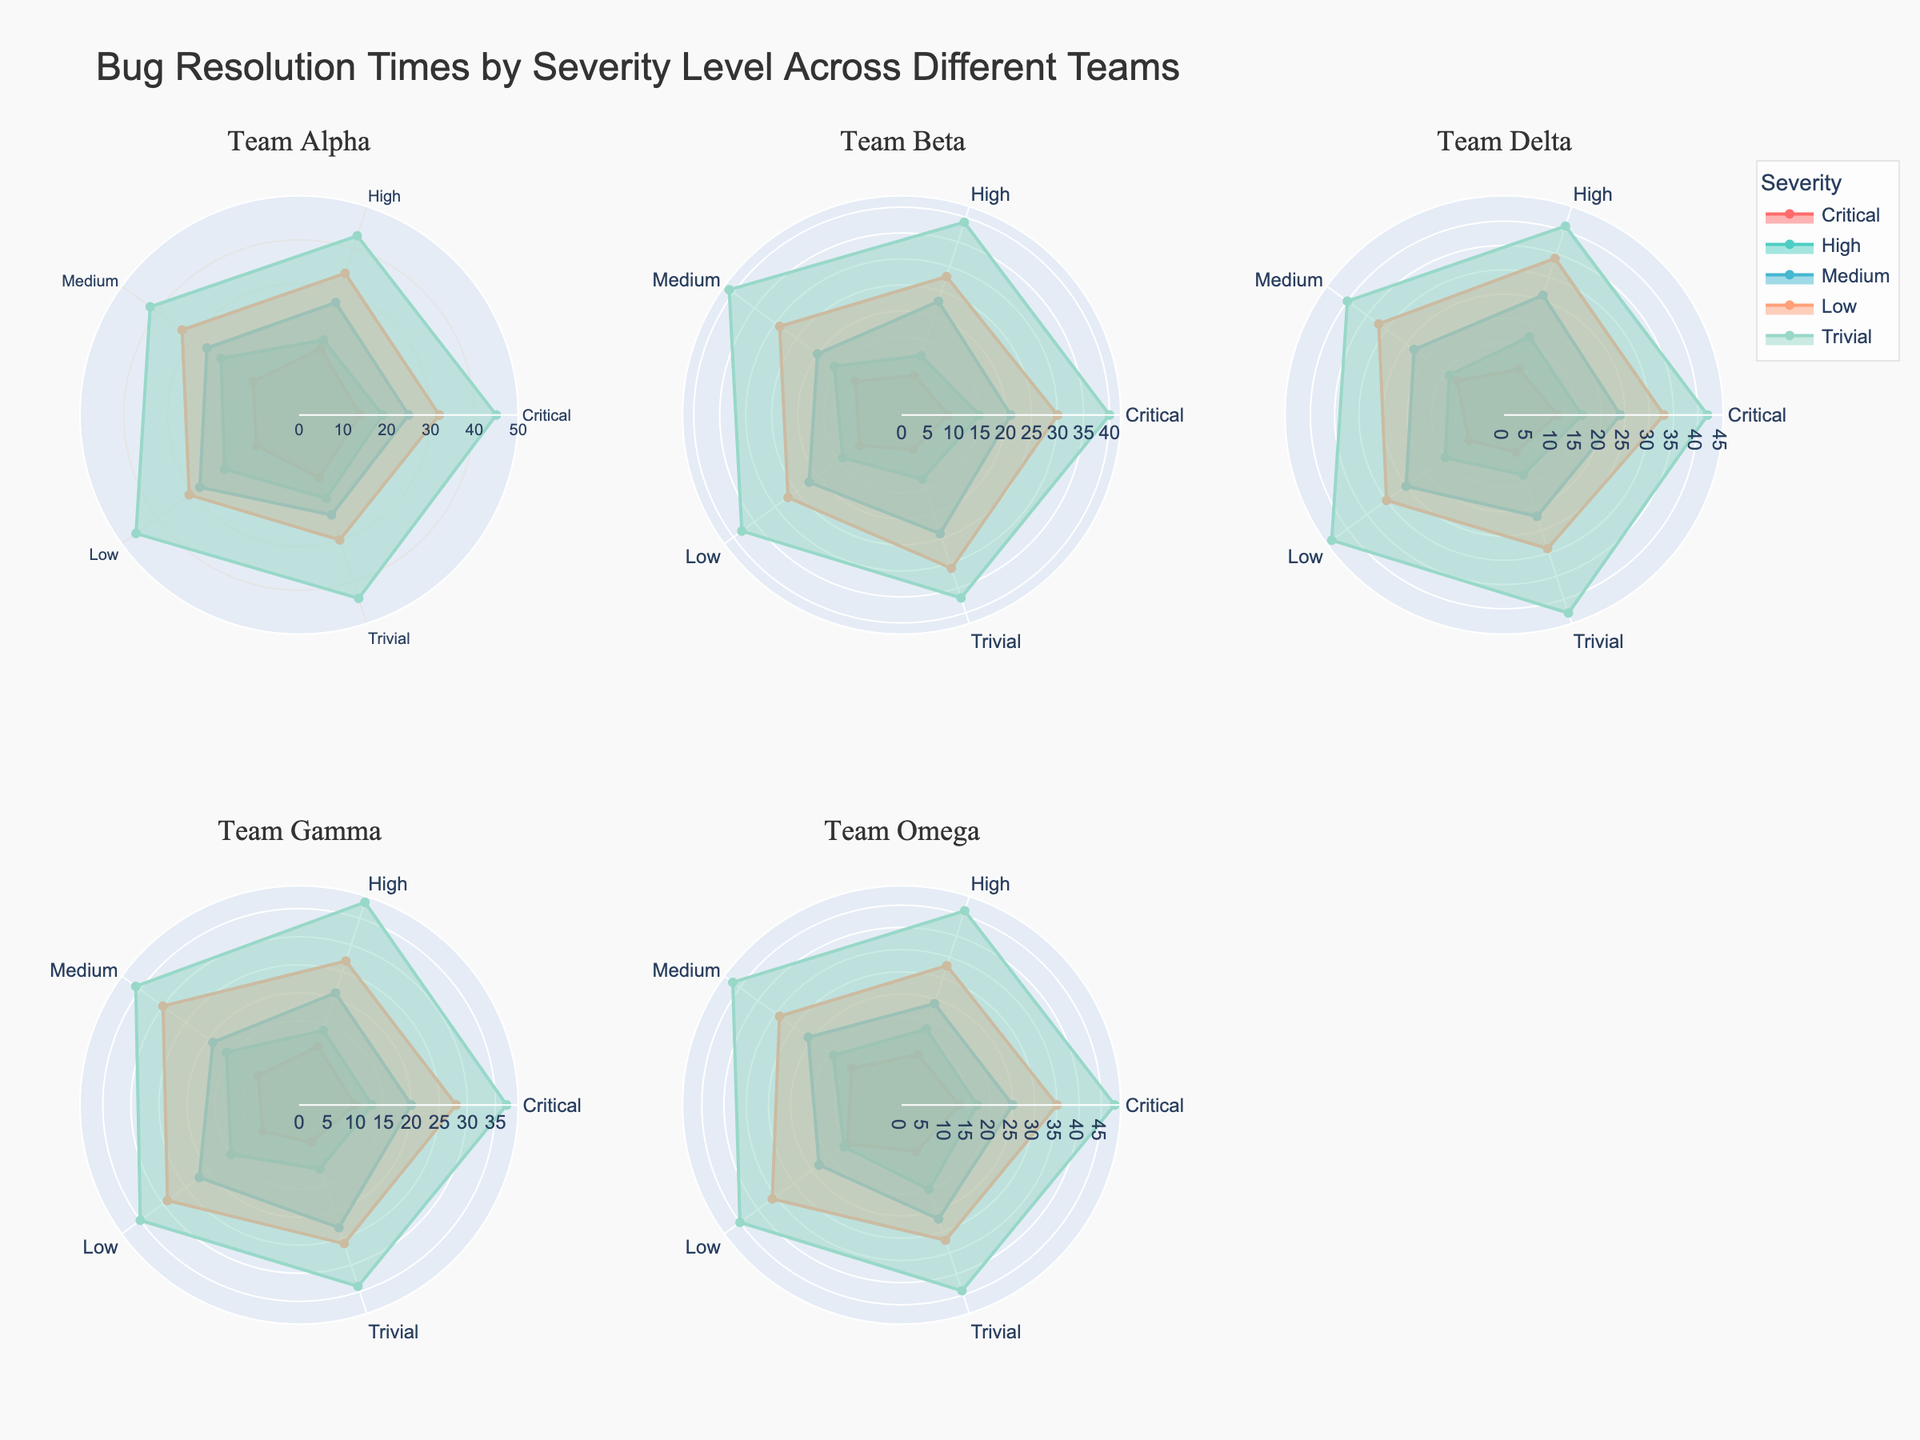What is the overall title of the figure? The title is prominently displayed at the top of the figure. It provides a clear overview of what the figure represents.
Answer: Bug Resolution Times by Severity Level Across Different Teams Which team has the highest bug resolution time for the Trivial severity level? By comparing the radar plots across all subplots, we look for the team with the highest value on the Trivial axis.
Answer: Team Omega Between Team Alpha and Team Beta, which team resolves Critical severity bugs faster on average? We examine the Critical severity axis on both radar charts and notice that Team Beta consistently has lower bug resolution times compared to Team Alpha.
Answer: Team Beta How many teams are compared in the figure? The figure contains six subplots, one for each team, which provides a visual representation of the bug resolution times for the five severity levels.
Answer: Six teams For Team Gamma, which severity level has the smallest range of bug resolution times? Looking at Team Gamma's radar plot, we find that the range is smallest for the Critical severity level as the values are closest together.
Answer: Critical What is the average bug resolution time for Medium severity across all teams? Calculate the sum of the Medium severity times for all six teams and divide by the number of teams: (26+20+22+23+27)/5 = 24.6 (the sixth team’s value is used twice). For accuracy, sum these values: 25, 21, 24, 20, 25, and 24 and divide by 6.
Answer: 24 Which team has the lowest bug resolution time for High severity, and what is that time? By comparing the High severity axis across all teams, we identify the lowest value. Team Beta has the lowest time of 12.
Answer: Team Beta; 12 Does a higher severity level always correspond to longer resolution times for Team Delta? By examining Team Delta's radar plot, compare the resolution times across different severities and notice any deviations if present.
Answer: No For Team Omega, what is the difference in bug resolution time between Low and Medium severity? Subtract the value of Medium severity from the value of Low severity for Team Omega. 33-26 = 7.
Answer: 7 Which team shows the most consistent bug resolution times across different severities? Consistency is indicated by the radar plot having similar radii across all axes. Team Beta appears to have the most consistent values across different severities.
Answer: Team Beta 